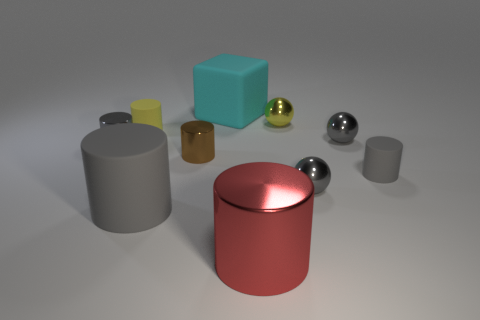Subtract all green cubes. How many gray cylinders are left? 3 Subtract all large red cylinders. How many cylinders are left? 5 Subtract all yellow cylinders. How many cylinders are left? 5 Subtract all cyan cylinders. Subtract all purple cubes. How many cylinders are left? 6 Subtract all cylinders. How many objects are left? 4 Add 1 tiny red rubber blocks. How many tiny red rubber blocks exist? 1 Subtract 0 blue balls. How many objects are left? 10 Subtract all tiny brown things. Subtract all tiny things. How many objects are left? 2 Add 7 metal cylinders. How many metal cylinders are left? 10 